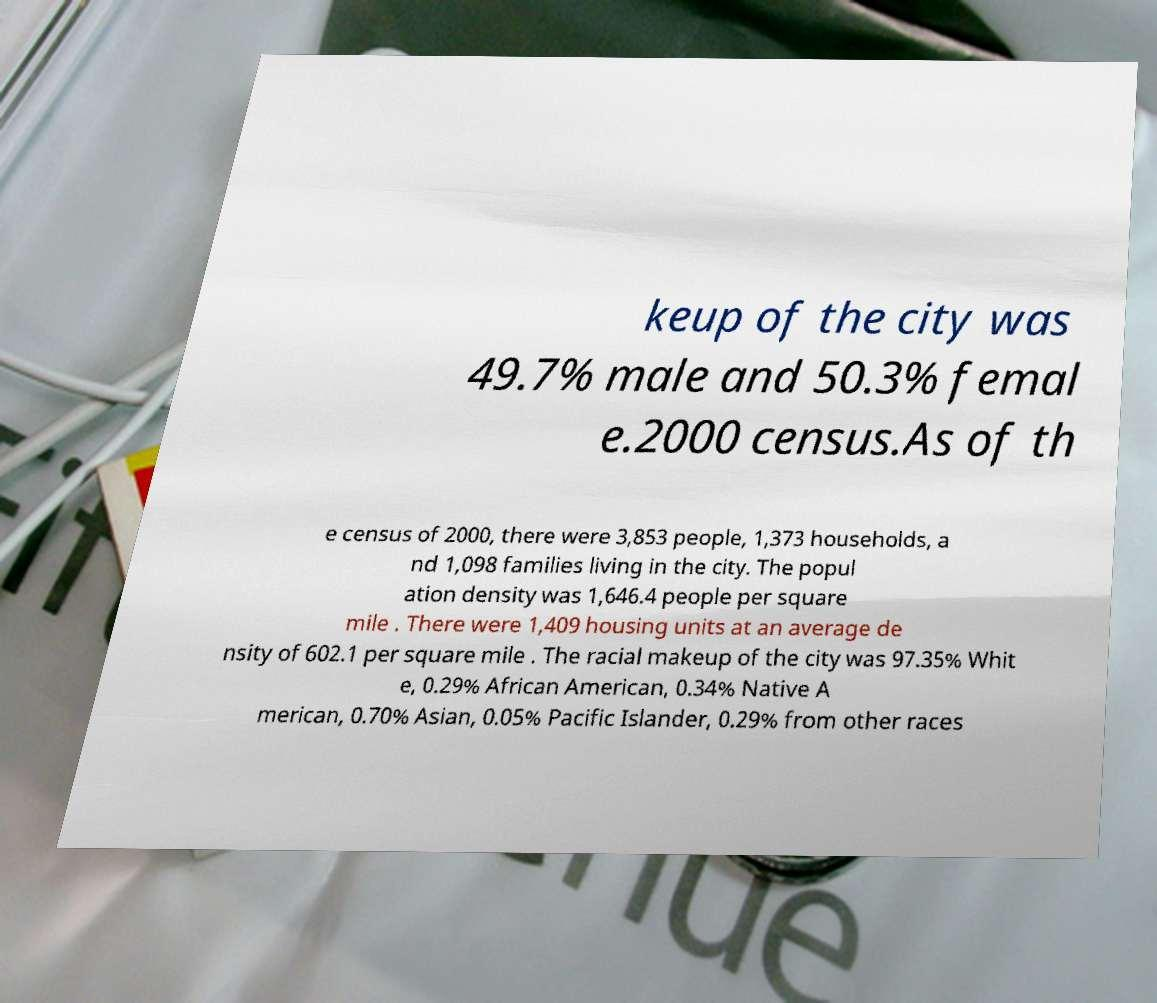Can you accurately transcribe the text from the provided image for me? keup of the city was 49.7% male and 50.3% femal e.2000 census.As of th e census of 2000, there were 3,853 people, 1,373 households, a nd 1,098 families living in the city. The popul ation density was 1,646.4 people per square mile . There were 1,409 housing units at an average de nsity of 602.1 per square mile . The racial makeup of the city was 97.35% Whit e, 0.29% African American, 0.34% Native A merican, 0.70% Asian, 0.05% Pacific Islander, 0.29% from other races 